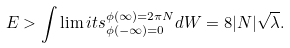<formula> <loc_0><loc_0><loc_500><loc_500>E > \int \lim i t s _ { \phi ( - \infty ) = 0 } ^ { \phi ( \infty ) = 2 \pi N } d W = 8 | N | \sqrt { \lambda } .</formula> 